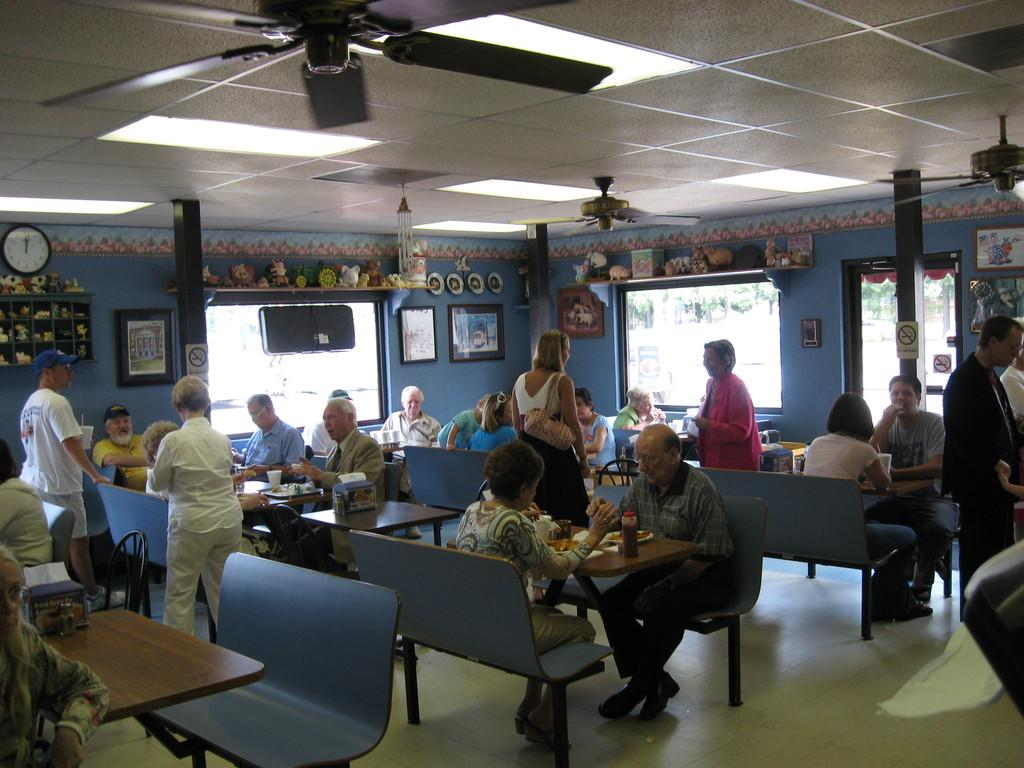What are the people in the image doing? The people in the image are sitting on a bench. Where is the bench located in relation to the table? The bench is in front of a table. What type of establishment might the setting be in the image? The setting appears to be inside a restaurant. What type of cooling system is visible in the image? There are ceiling fans visible in the image. What type of lighting is present in the image? There are lights visible in the image. What type of yoke is being used by the people sitting on the bench in the image? There is no yoke present in the image; the people are simply sitting on a bench. 